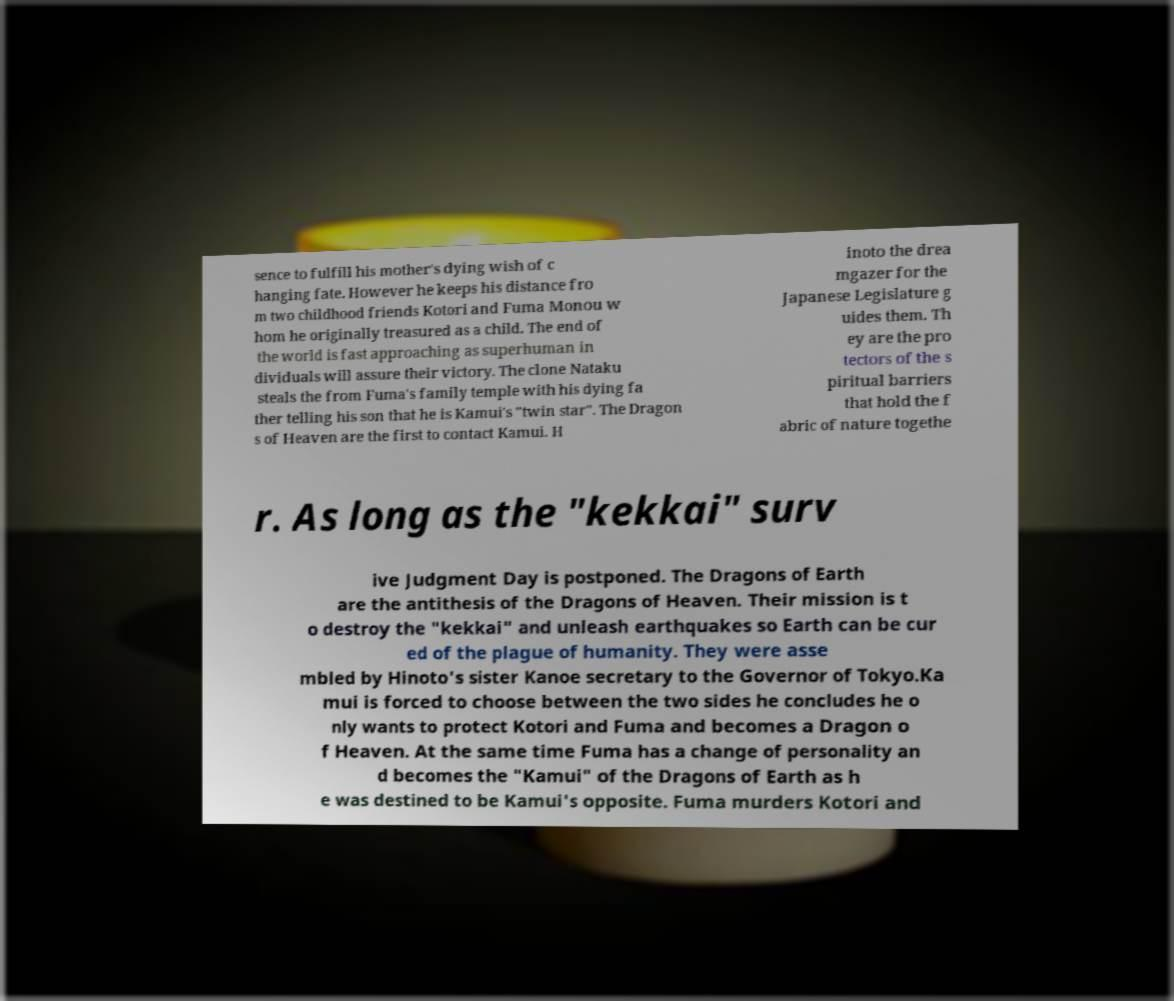Could you assist in decoding the text presented in this image and type it out clearly? sence to fulfill his mother's dying wish of c hanging fate. However he keeps his distance fro m two childhood friends Kotori and Fuma Monou w hom he originally treasured as a child. The end of the world is fast approaching as superhuman in dividuals will assure their victory. The clone Nataku steals the from Fuma's family temple with his dying fa ther telling his son that he is Kamui's "twin star". The Dragon s of Heaven are the first to contact Kamui. H inoto the drea mgazer for the Japanese Legislature g uides them. Th ey are the pro tectors of the s piritual barriers that hold the f abric of nature togethe r. As long as the "kekkai" surv ive Judgment Day is postponed. The Dragons of Earth are the antithesis of the Dragons of Heaven. Their mission is t o destroy the "kekkai" and unleash earthquakes so Earth can be cur ed of the plague of humanity. They were asse mbled by Hinoto's sister Kanoe secretary to the Governor of Tokyo.Ka mui is forced to choose between the two sides he concludes he o nly wants to protect Kotori and Fuma and becomes a Dragon o f Heaven. At the same time Fuma has a change of personality an d becomes the "Kamui" of the Dragons of Earth as h e was destined to be Kamui's opposite. Fuma murders Kotori and 